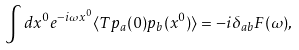Convert formula to latex. <formula><loc_0><loc_0><loc_500><loc_500>\int d x ^ { 0 } e ^ { - i \omega x ^ { 0 } } \langle T p _ { a } ( 0 ) p _ { b } ( x ^ { 0 } ) \rangle = - i \delta _ { a b } F ( \omega ) ,</formula> 